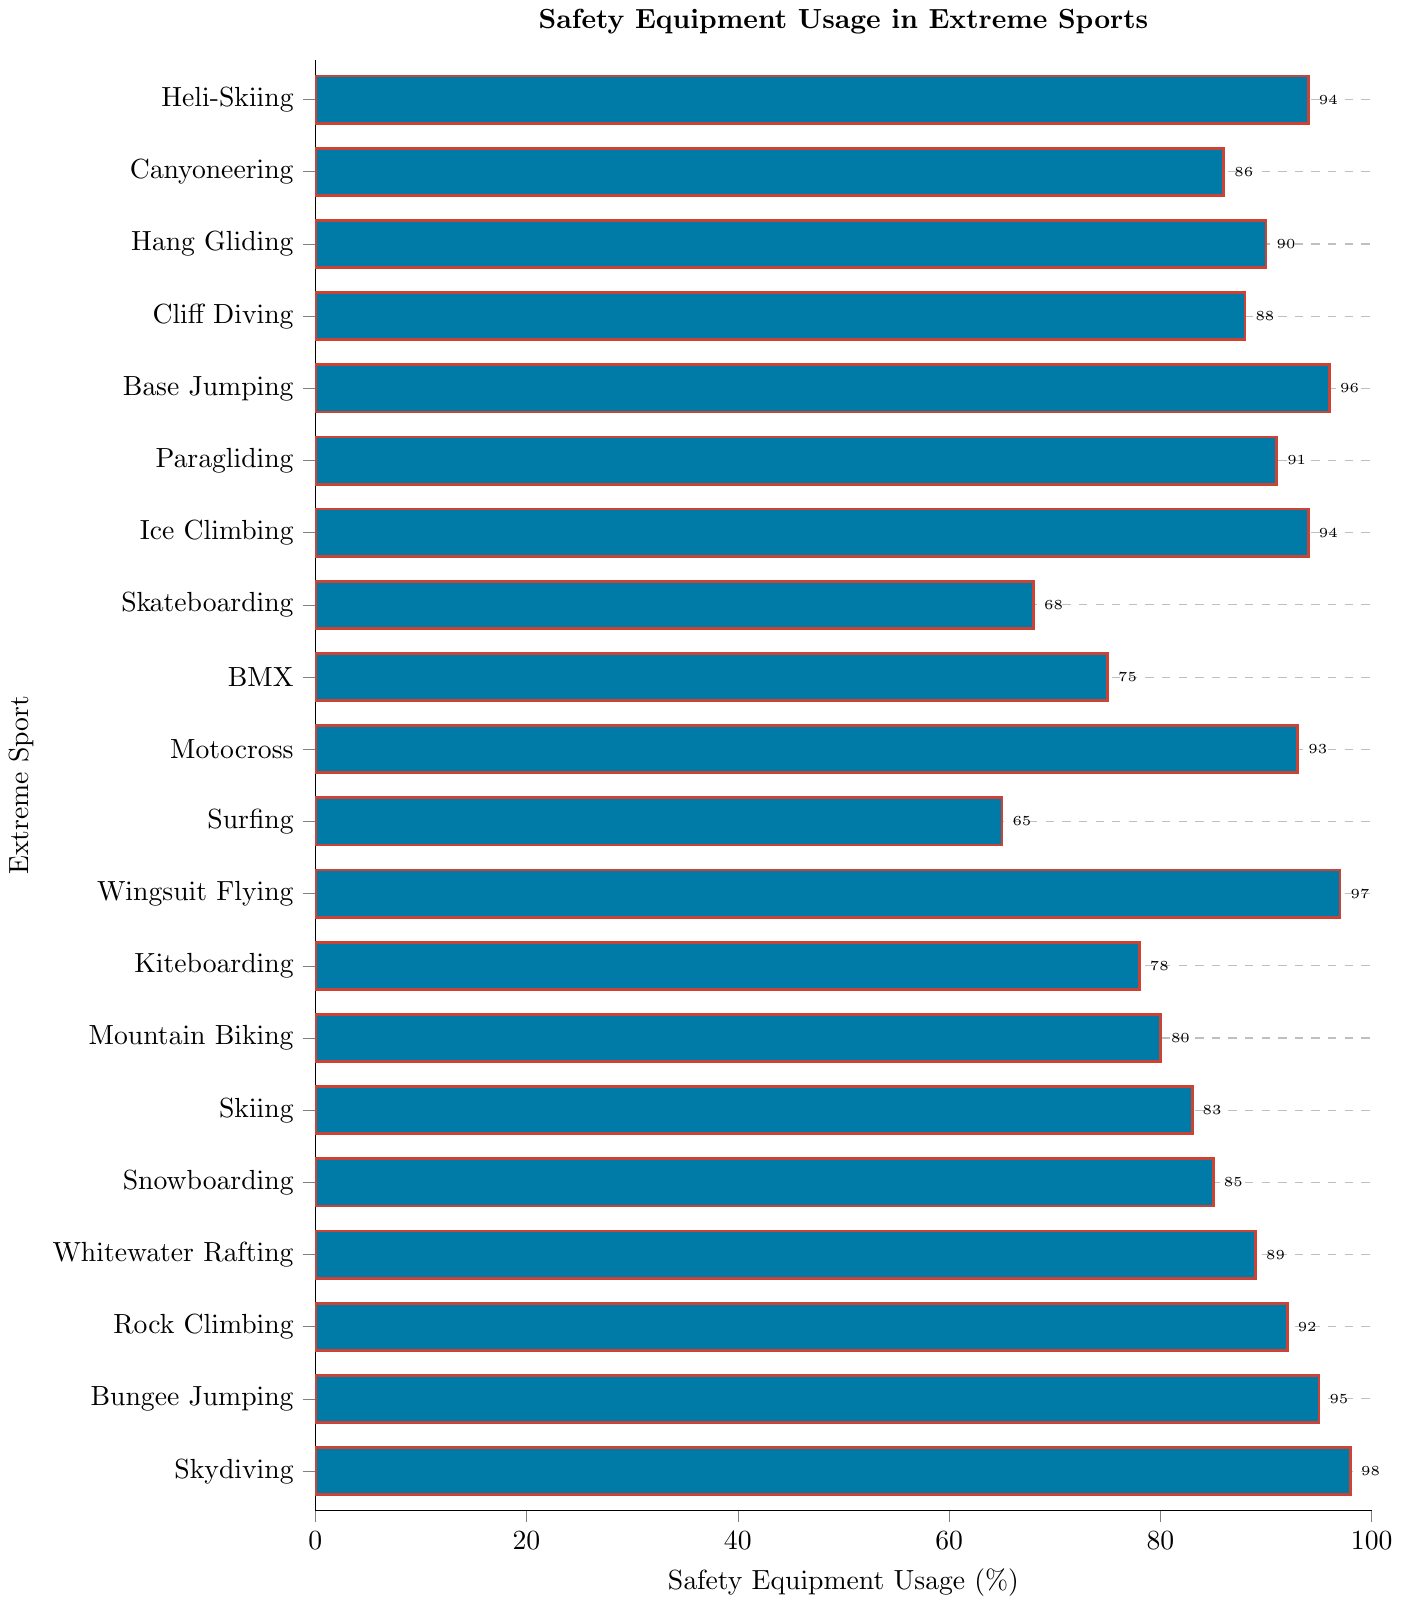What's the sport with the highest percentage of safety equipment usage? Identify the bars with the highest length and check their labels; in this case, it is the Skydiving bar with 98%.
Answer: Skydiving Which sport has the lowest percentage of safety equipment usage? Identify the shortest bar and check its label; this is Surfing at 65%.
Answer: Surfing Compare skateboarding and BMX: which sport has a higher percentage of safety equipment usage? Locate the bars for Skateboarding and BMX, and compare their lengths. BMX has 75% while Skateboarding has 68%.
Answer: BMX What is the difference in safety equipment usage between Wingsuit Flying and Paragliding? Find the bars for Wingsuit Flying (97%) and Paragliding (91%), then calculate the difference: 97 - 91 = 6%.
Answer: 6% Calculate the average percentage of safety equipment usage across all listed sports. Sum all the percentages and divide by the number of sports (20). (98 + 95 + 92 + 89 + 85 + 83 + 80 + 78 + 97 + 65 + 93 + 75 + 68 + 94 + 91 + 96 + 88 + 90 + 86 + 94) / 20 = 87.1
Answer: 87.1 What's the combined percentage of safety equipment usage for the three sports with the highest usage percentages? Identify the top three sports: Skydiving (98%), Wingsuit Flying (97%), and Base Jumping (96%), then sum their percentages: 98 + 97 + 96 = 291%
Answer: 291% Are there any sports with exactly 95% usage of safety equipment? Check the data for any bars at exactly 95%. Bungee Jumping matches this percentage.
Answer: Bungee Jumping Which group of sports, those with usage above 90% or those below, contains more entries? Count the number of sports with percentages above 90% and below 90%. Above 90%: Skydiving, Bungee Jumping, Rock Climbing, Wingsuit Flying, Motocross, Ice Climbing, Base Jumping, Paragliding, Heli-Skiing (9 sports); below 90%: Whitewater Rafting, Snowboarding, Skiing, Mountain Biking, Kiteboarding, Skateboarding, Surfing, BMX, Canyoneering, Cliff Diving, Hang Gliding (11 sports).
Answer: Below 90% Does hang gliding or cliff diving have a higher safety equipment usage percentage? Locate the bars for Hang Gliding (90%) and Cliff Diving (88%); Hang Gliding is higher.
Answer: Hang Gliding What's the range of safety equipment usage percentages among all sports shown? Find the highest (Skydiving at 98%) and lowest (Surfing at 65%) percentages, then subtract the lowest from the highest: 98 - 65 = 33.
Answer: 33 